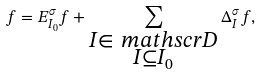<formula> <loc_0><loc_0><loc_500><loc_500>f = E _ { I _ { 0 } } ^ { \sigma } f + \sum _ { \substack { I \in \ m a t h s c r { D } \\ I \subseteq I _ { 0 } } } \Delta _ { I } ^ { \sigma } f ,</formula> 